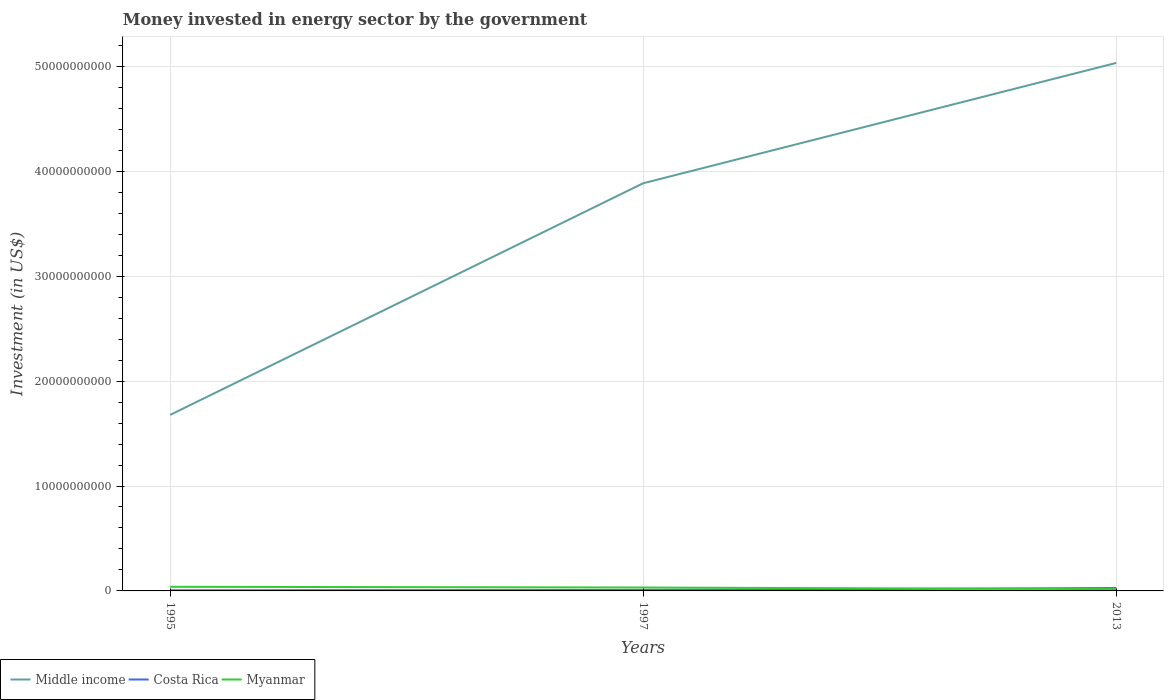Does the line corresponding to Middle income intersect with the line corresponding to Costa Rica?
Make the answer very short. No. Is the number of lines equal to the number of legend labels?
Provide a succinct answer. Yes. Across all years, what is the maximum money spent in energy sector in Myanmar?
Offer a very short reply. 1.70e+08. What is the total money spent in energy sector in Myanmar in the graph?
Provide a succinct answer. 1.55e+08. What is the difference between the highest and the second highest money spent in energy sector in Costa Rica?
Your answer should be compact. 2.16e+08. Is the money spent in energy sector in Costa Rica strictly greater than the money spent in energy sector in Myanmar over the years?
Give a very brief answer. No. How many years are there in the graph?
Your response must be concise. 3. Does the graph contain any zero values?
Offer a very short reply. No. Does the graph contain grids?
Provide a short and direct response. Yes. How many legend labels are there?
Offer a terse response. 3. What is the title of the graph?
Provide a short and direct response. Money invested in energy sector by the government. What is the label or title of the X-axis?
Your answer should be compact. Years. What is the label or title of the Y-axis?
Ensure brevity in your answer.  Investment (in US$). What is the Investment (in US$) in Middle income in 1995?
Your answer should be compact. 1.68e+1. What is the Investment (in US$) of Costa Rica in 1995?
Give a very brief answer. 5.81e+07. What is the Investment (in US$) in Myanmar in 1995?
Your answer should be very brief. 3.94e+08. What is the Investment (in US$) in Middle income in 1997?
Give a very brief answer. 3.89e+1. What is the Investment (in US$) in Costa Rica in 1997?
Your response must be concise. 9.29e+07. What is the Investment (in US$) in Myanmar in 1997?
Your response must be concise. 3.25e+08. What is the Investment (in US$) of Middle income in 2013?
Provide a succinct answer. 5.03e+1. What is the Investment (in US$) in Costa Rica in 2013?
Your answer should be very brief. 2.75e+08. What is the Investment (in US$) in Myanmar in 2013?
Your answer should be compact. 1.70e+08. Across all years, what is the maximum Investment (in US$) in Middle income?
Offer a terse response. 5.03e+1. Across all years, what is the maximum Investment (in US$) in Costa Rica?
Ensure brevity in your answer.  2.75e+08. Across all years, what is the maximum Investment (in US$) in Myanmar?
Make the answer very short. 3.94e+08. Across all years, what is the minimum Investment (in US$) of Middle income?
Offer a terse response. 1.68e+1. Across all years, what is the minimum Investment (in US$) in Costa Rica?
Provide a succinct answer. 5.81e+07. Across all years, what is the minimum Investment (in US$) of Myanmar?
Give a very brief answer. 1.70e+08. What is the total Investment (in US$) of Middle income in the graph?
Make the answer very short. 1.06e+11. What is the total Investment (in US$) in Costa Rica in the graph?
Ensure brevity in your answer.  4.26e+08. What is the total Investment (in US$) in Myanmar in the graph?
Offer a terse response. 8.89e+08. What is the difference between the Investment (in US$) in Middle income in 1995 and that in 1997?
Keep it short and to the point. -2.21e+1. What is the difference between the Investment (in US$) in Costa Rica in 1995 and that in 1997?
Provide a succinct answer. -3.48e+07. What is the difference between the Investment (in US$) in Myanmar in 1995 and that in 1997?
Provide a short and direct response. 6.90e+07. What is the difference between the Investment (in US$) of Middle income in 1995 and that in 2013?
Ensure brevity in your answer.  -3.35e+1. What is the difference between the Investment (in US$) in Costa Rica in 1995 and that in 2013?
Your answer should be very brief. -2.16e+08. What is the difference between the Investment (in US$) in Myanmar in 1995 and that in 2013?
Keep it short and to the point. 2.24e+08. What is the difference between the Investment (in US$) in Middle income in 1997 and that in 2013?
Make the answer very short. -1.15e+1. What is the difference between the Investment (in US$) of Costa Rica in 1997 and that in 2013?
Provide a succinct answer. -1.82e+08. What is the difference between the Investment (in US$) in Myanmar in 1997 and that in 2013?
Your answer should be very brief. 1.55e+08. What is the difference between the Investment (in US$) in Middle income in 1995 and the Investment (in US$) in Costa Rica in 1997?
Offer a very short reply. 1.67e+1. What is the difference between the Investment (in US$) of Middle income in 1995 and the Investment (in US$) of Myanmar in 1997?
Offer a terse response. 1.65e+1. What is the difference between the Investment (in US$) of Costa Rica in 1995 and the Investment (in US$) of Myanmar in 1997?
Make the answer very short. -2.67e+08. What is the difference between the Investment (in US$) of Middle income in 1995 and the Investment (in US$) of Costa Rica in 2013?
Your response must be concise. 1.65e+1. What is the difference between the Investment (in US$) in Middle income in 1995 and the Investment (in US$) in Myanmar in 2013?
Provide a succinct answer. 1.66e+1. What is the difference between the Investment (in US$) in Costa Rica in 1995 and the Investment (in US$) in Myanmar in 2013?
Keep it short and to the point. -1.12e+08. What is the difference between the Investment (in US$) in Middle income in 1997 and the Investment (in US$) in Costa Rica in 2013?
Your answer should be very brief. 3.86e+1. What is the difference between the Investment (in US$) of Middle income in 1997 and the Investment (in US$) of Myanmar in 2013?
Make the answer very short. 3.87e+1. What is the difference between the Investment (in US$) in Costa Rica in 1997 and the Investment (in US$) in Myanmar in 2013?
Provide a short and direct response. -7.71e+07. What is the average Investment (in US$) of Middle income per year?
Ensure brevity in your answer.  3.53e+1. What is the average Investment (in US$) of Costa Rica per year?
Make the answer very short. 1.42e+08. What is the average Investment (in US$) in Myanmar per year?
Your answer should be compact. 2.96e+08. In the year 1995, what is the difference between the Investment (in US$) in Middle income and Investment (in US$) in Costa Rica?
Provide a succinct answer. 1.67e+1. In the year 1995, what is the difference between the Investment (in US$) in Middle income and Investment (in US$) in Myanmar?
Offer a terse response. 1.64e+1. In the year 1995, what is the difference between the Investment (in US$) in Costa Rica and Investment (in US$) in Myanmar?
Your answer should be very brief. -3.36e+08. In the year 1997, what is the difference between the Investment (in US$) of Middle income and Investment (in US$) of Costa Rica?
Give a very brief answer. 3.88e+1. In the year 1997, what is the difference between the Investment (in US$) in Middle income and Investment (in US$) in Myanmar?
Your response must be concise. 3.85e+1. In the year 1997, what is the difference between the Investment (in US$) in Costa Rica and Investment (in US$) in Myanmar?
Make the answer very short. -2.32e+08. In the year 2013, what is the difference between the Investment (in US$) in Middle income and Investment (in US$) in Costa Rica?
Your answer should be very brief. 5.00e+1. In the year 2013, what is the difference between the Investment (in US$) in Middle income and Investment (in US$) in Myanmar?
Offer a very short reply. 5.02e+1. In the year 2013, what is the difference between the Investment (in US$) of Costa Rica and Investment (in US$) of Myanmar?
Make the answer very short. 1.05e+08. What is the ratio of the Investment (in US$) of Middle income in 1995 to that in 1997?
Provide a short and direct response. 0.43. What is the ratio of the Investment (in US$) of Costa Rica in 1995 to that in 1997?
Keep it short and to the point. 0.63. What is the ratio of the Investment (in US$) of Myanmar in 1995 to that in 1997?
Provide a succinct answer. 1.21. What is the ratio of the Investment (in US$) of Middle income in 1995 to that in 2013?
Your answer should be very brief. 0.33. What is the ratio of the Investment (in US$) of Costa Rica in 1995 to that in 2013?
Give a very brief answer. 0.21. What is the ratio of the Investment (in US$) in Myanmar in 1995 to that in 2013?
Provide a short and direct response. 2.32. What is the ratio of the Investment (in US$) in Middle income in 1997 to that in 2013?
Offer a terse response. 0.77. What is the ratio of the Investment (in US$) in Costa Rica in 1997 to that in 2013?
Your answer should be compact. 0.34. What is the ratio of the Investment (in US$) of Myanmar in 1997 to that in 2013?
Your response must be concise. 1.91. What is the difference between the highest and the second highest Investment (in US$) of Middle income?
Provide a succinct answer. 1.15e+1. What is the difference between the highest and the second highest Investment (in US$) in Costa Rica?
Ensure brevity in your answer.  1.82e+08. What is the difference between the highest and the second highest Investment (in US$) of Myanmar?
Give a very brief answer. 6.90e+07. What is the difference between the highest and the lowest Investment (in US$) in Middle income?
Offer a terse response. 3.35e+1. What is the difference between the highest and the lowest Investment (in US$) in Costa Rica?
Ensure brevity in your answer.  2.16e+08. What is the difference between the highest and the lowest Investment (in US$) of Myanmar?
Make the answer very short. 2.24e+08. 